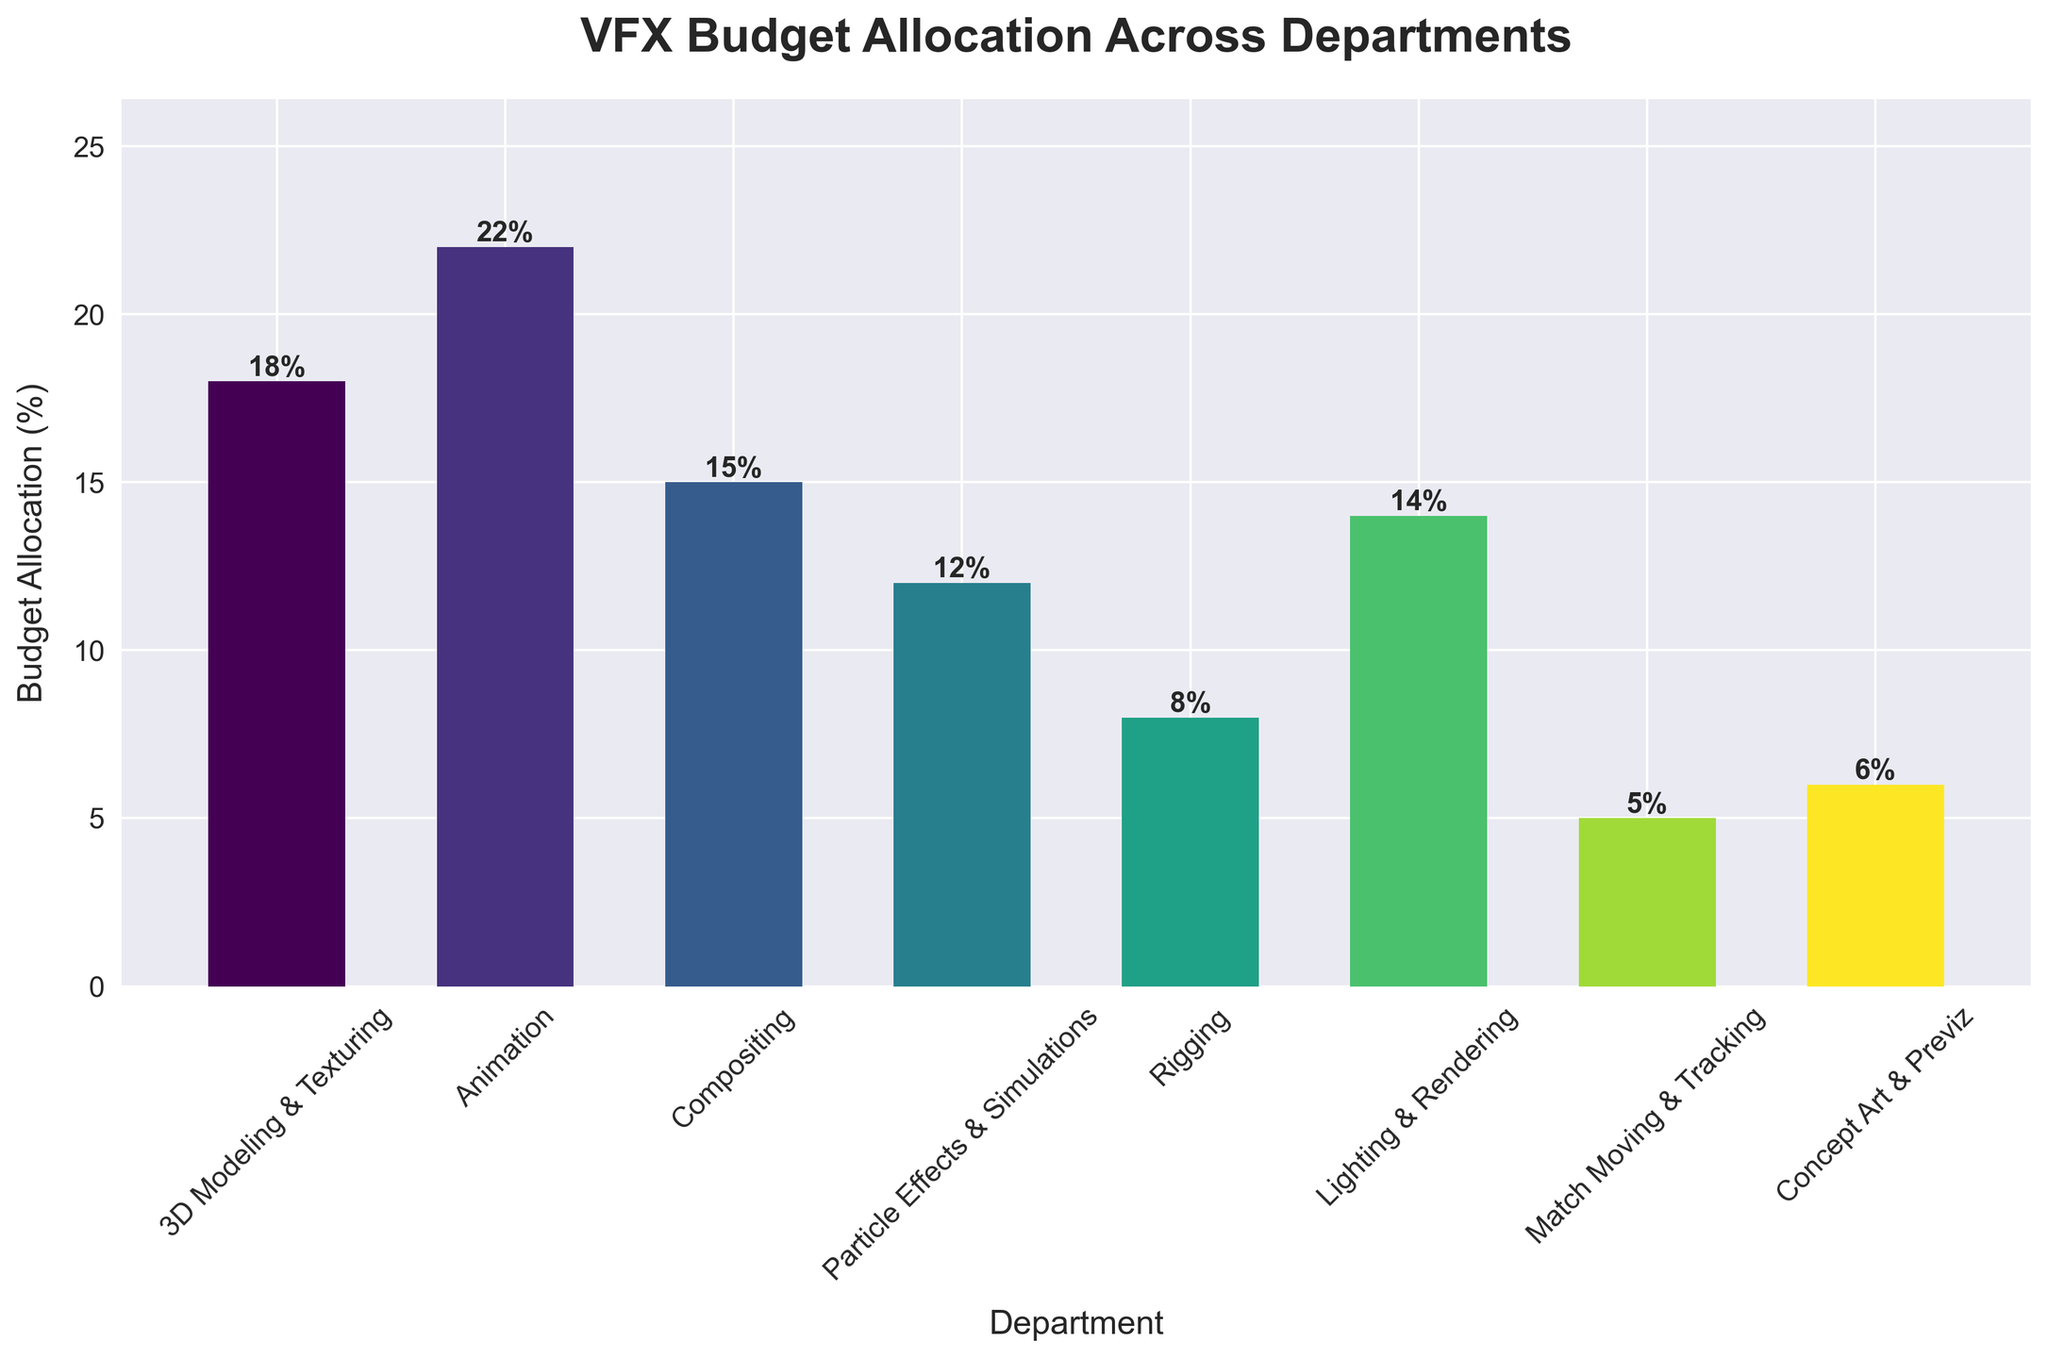What is the total budget allocation for 3D Modeling & Texturing and Animation? To find the total budget allocation for 3D Modeling & Texturing and Animation, add their individual percentages. 3D Modeling & Texturing is allocated 18%, and Animation is allocated 22%. Therefore, the total is 18 + 22 = 40%.
Answer: 40% Which department receives the highest budget allocation, and what is the percentage? To determine the department with the highest budget allocation, look for the tallest bar. The Animation department receives the highest allocation with 22%.
Answer: Animation, 22% What is the difference in budget allocation between Compositing and Rigging? To find the difference, subtract the budget allocation of Rigging from that of Compositing. Compositing has 15%, and Rigging has 8%, so the difference is 15 - 8 = 7%.
Answer: 7% How many departments have a budget allocation less than 10%? Count the number of bars that correspond to budget percentages less than 10%. The departments are Rigging (8%), Match Moving & Tracking (5%), and Concept Art & Previz (6%). Thus, there are 3 departments.
Answer: 3 What is the average budget allocation across all departments? To calculate the average, sum up all the budget allocation percentages and then divide by the total number of departments. The total sum is 18 + 22 + 15 + 12 + 8 + 14 + 5 + 6 = 100. There are 8 departments, so the average is 100 / 8 = 12.5%.
Answer: 12.5% Which department has the lowest budget allocation, and what is the percentage? To find the department with the lowest budget allocation, look for the shortest bar. Match Moving & Tracking receives the lowest allocation with 5%.
Answer: Match Moving & Tracking, 5% Is the budget allocation for Lighting & Rendering greater than that for Particle Effects & Simulations? Compare the heights of the bars for Lighting & Rendering and Particle Effects & Simulations. Lighting & Rendering is allocated 14%, and Particle Effects & Simulations is allocated 12%. Since 14% is greater than 12%, the answer is yes.
Answer: Yes What is the combined budget allocation for Rigging, Match Moving & Tracking, and Concept Art & Previz? Add the budget allocations of Rigging, Match Moving & Tracking, and Concept Art & Previz. The values are 8% + 5% + 6%, which sum to 19%.
Answer: 19% What is the median budget allocation across all departments? To find the median, first list the budget allocations in ascending order: 5%, 6%, 8%, 12%, 14%, 15%, 18%, 22%. Since there are 8 departments, the median is the average of the 4th and 5th values. These values are 12% and 14%, so the median is (12 + 14) / 2 = 13%.
Answer: 13% Which two departments have a combined budget allocation of 30%? Look for two bars whose heights sum to 30%. The departments are 3D Modeling & Texturing (18%) and Compositing (15%), which combined sum to 33%. Animation (22%) and Match Moving & Tracking (5%) sum to 27%. Animation (22%) and Rigging (8%) sum to 30%. Therefore, the departments are Animation and Rigging.
Answer: Animation and Rigging 